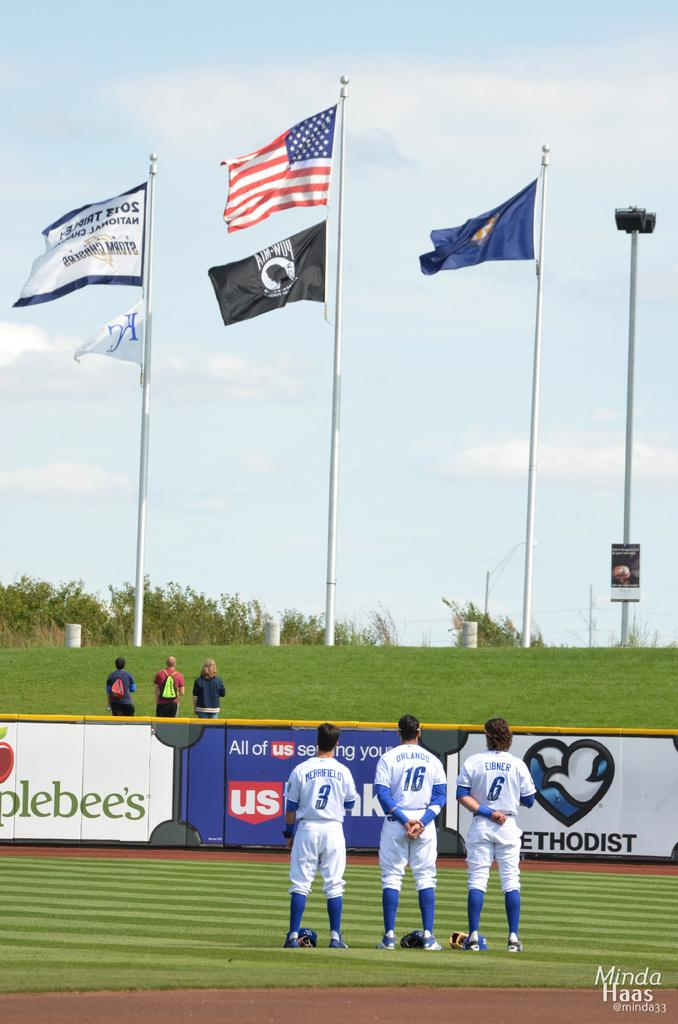<image>
Provide a brief description of the given image. Three baseball players wearing the numbers 3, 16, and 6 are standing to attention in front of five flags. 